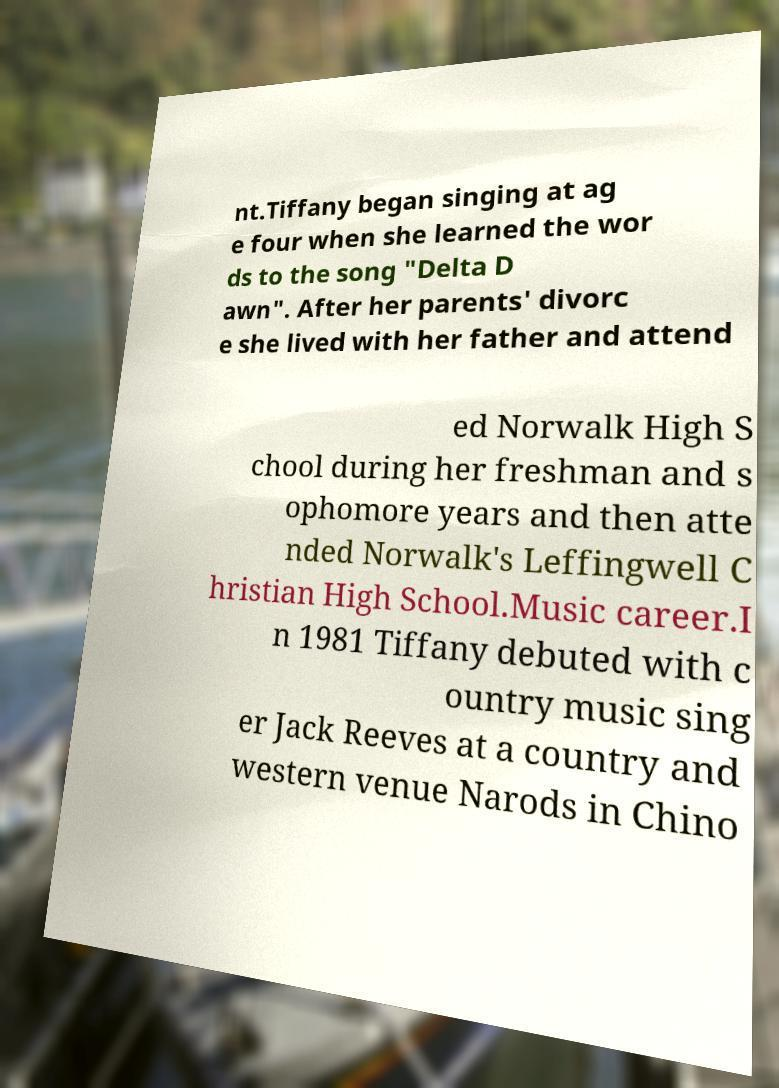Please read and relay the text visible in this image. What does it say? nt.Tiffany began singing at ag e four when she learned the wor ds to the song "Delta D awn". After her parents' divorc e she lived with her father and attend ed Norwalk High S chool during her freshman and s ophomore years and then atte nded Norwalk's Leffingwell C hristian High School.Music career.I n 1981 Tiffany debuted with c ountry music sing er Jack Reeves at a country and western venue Narods in Chino 